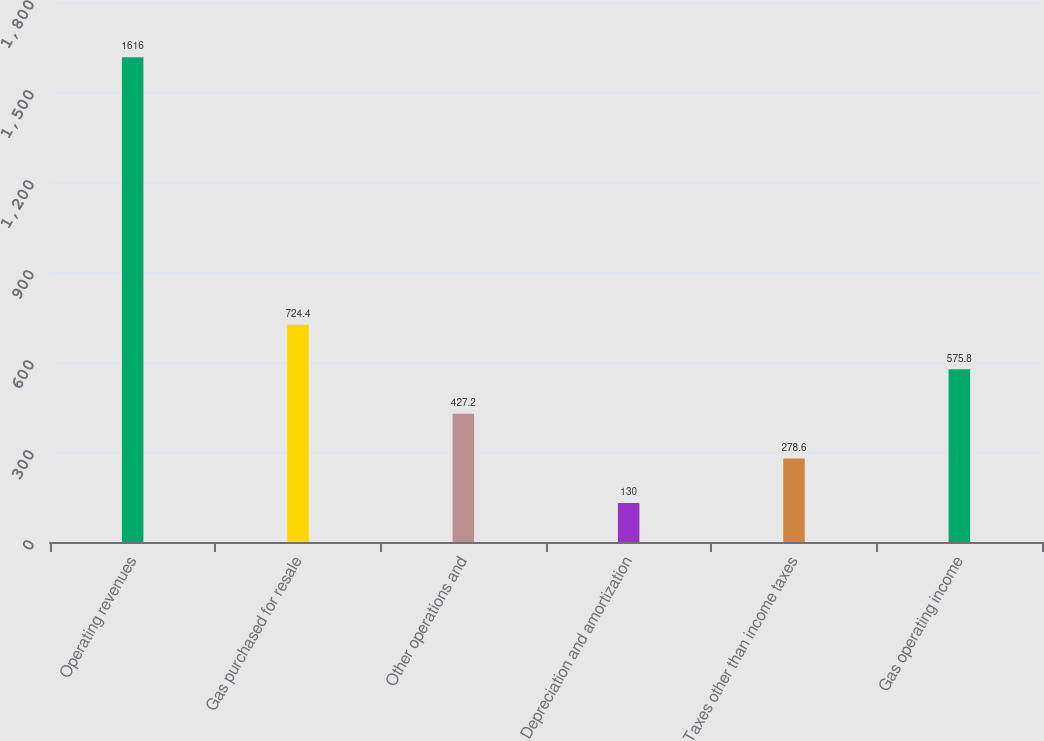Convert chart. <chart><loc_0><loc_0><loc_500><loc_500><bar_chart><fcel>Operating revenues<fcel>Gas purchased for resale<fcel>Other operations and<fcel>Depreciation and amortization<fcel>Taxes other than income taxes<fcel>Gas operating income<nl><fcel>1616<fcel>724.4<fcel>427.2<fcel>130<fcel>278.6<fcel>575.8<nl></chart> 